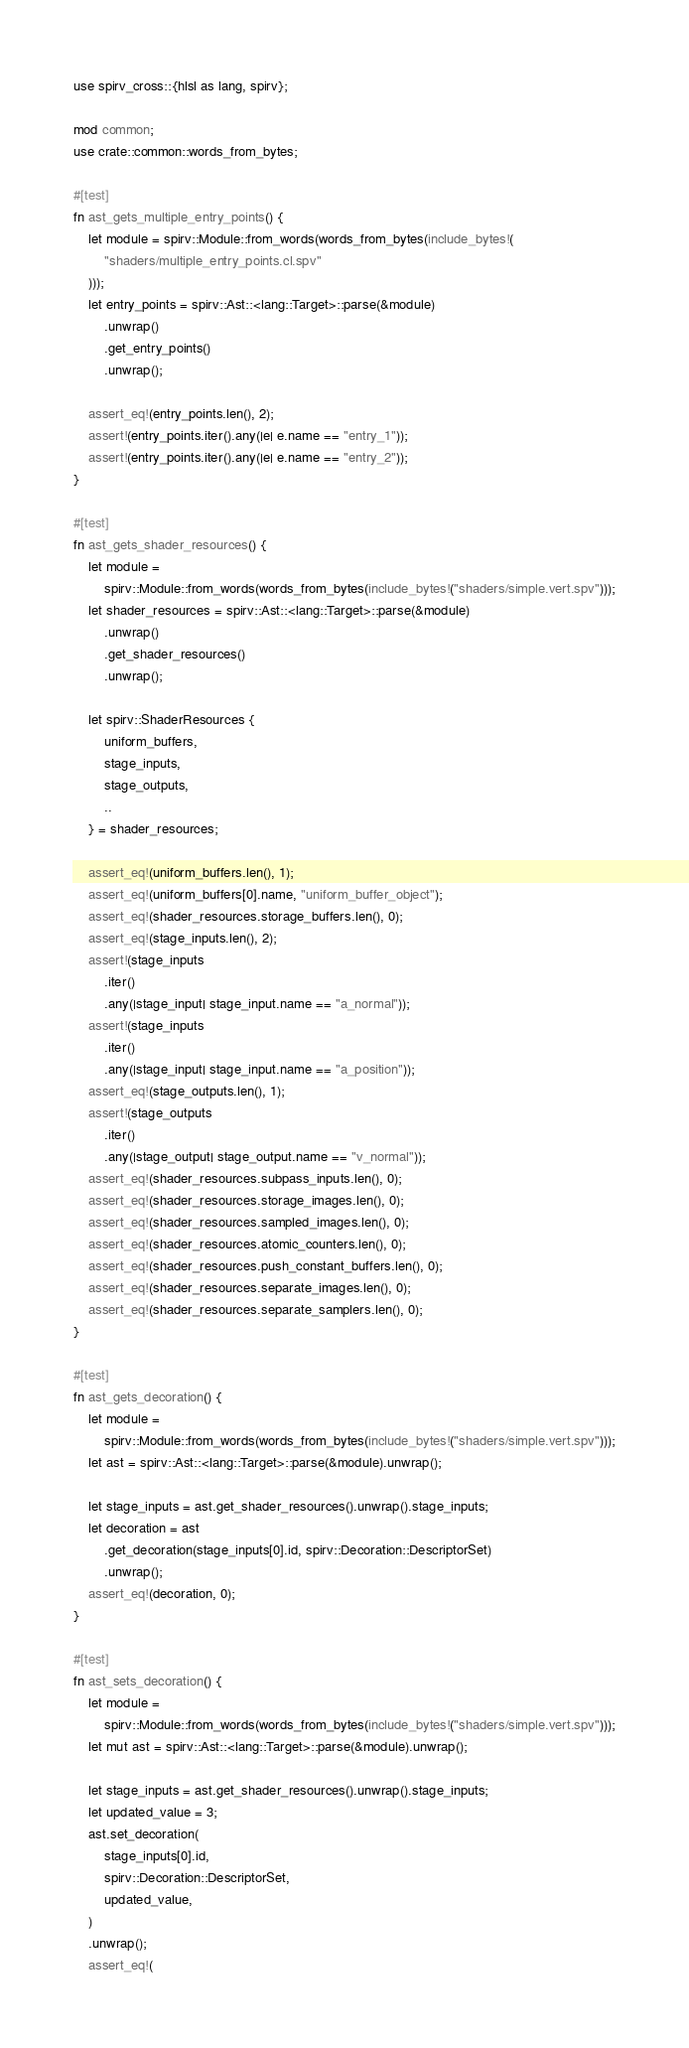<code> <loc_0><loc_0><loc_500><loc_500><_Rust_>use spirv_cross::{hlsl as lang, spirv};

mod common;
use crate::common::words_from_bytes;

#[test]
fn ast_gets_multiple_entry_points() {
    let module = spirv::Module::from_words(words_from_bytes(include_bytes!(
        "shaders/multiple_entry_points.cl.spv"
    )));
    let entry_points = spirv::Ast::<lang::Target>::parse(&module)
        .unwrap()
        .get_entry_points()
        .unwrap();

    assert_eq!(entry_points.len(), 2);
    assert!(entry_points.iter().any(|e| e.name == "entry_1"));
    assert!(entry_points.iter().any(|e| e.name == "entry_2"));
}

#[test]
fn ast_gets_shader_resources() {
    let module =
        spirv::Module::from_words(words_from_bytes(include_bytes!("shaders/simple.vert.spv")));
    let shader_resources = spirv::Ast::<lang::Target>::parse(&module)
        .unwrap()
        .get_shader_resources()
        .unwrap();

    let spirv::ShaderResources {
        uniform_buffers,
        stage_inputs,
        stage_outputs,
        ..
    } = shader_resources;

    assert_eq!(uniform_buffers.len(), 1);
    assert_eq!(uniform_buffers[0].name, "uniform_buffer_object");
    assert_eq!(shader_resources.storage_buffers.len(), 0);
    assert_eq!(stage_inputs.len(), 2);
    assert!(stage_inputs
        .iter()
        .any(|stage_input| stage_input.name == "a_normal"));
    assert!(stage_inputs
        .iter()
        .any(|stage_input| stage_input.name == "a_position"));
    assert_eq!(stage_outputs.len(), 1);
    assert!(stage_outputs
        .iter()
        .any(|stage_output| stage_output.name == "v_normal"));
    assert_eq!(shader_resources.subpass_inputs.len(), 0);
    assert_eq!(shader_resources.storage_images.len(), 0);
    assert_eq!(shader_resources.sampled_images.len(), 0);
    assert_eq!(shader_resources.atomic_counters.len(), 0);
    assert_eq!(shader_resources.push_constant_buffers.len(), 0);
    assert_eq!(shader_resources.separate_images.len(), 0);
    assert_eq!(shader_resources.separate_samplers.len(), 0);
}

#[test]
fn ast_gets_decoration() {
    let module =
        spirv::Module::from_words(words_from_bytes(include_bytes!("shaders/simple.vert.spv")));
    let ast = spirv::Ast::<lang::Target>::parse(&module).unwrap();

    let stage_inputs = ast.get_shader_resources().unwrap().stage_inputs;
    let decoration = ast
        .get_decoration(stage_inputs[0].id, spirv::Decoration::DescriptorSet)
        .unwrap();
    assert_eq!(decoration, 0);
}

#[test]
fn ast_sets_decoration() {
    let module =
        spirv::Module::from_words(words_from_bytes(include_bytes!("shaders/simple.vert.spv")));
    let mut ast = spirv::Ast::<lang::Target>::parse(&module).unwrap();

    let stage_inputs = ast.get_shader_resources().unwrap().stage_inputs;
    let updated_value = 3;
    ast.set_decoration(
        stage_inputs[0].id,
        spirv::Decoration::DescriptorSet,
        updated_value,
    )
    .unwrap();
    assert_eq!(</code> 